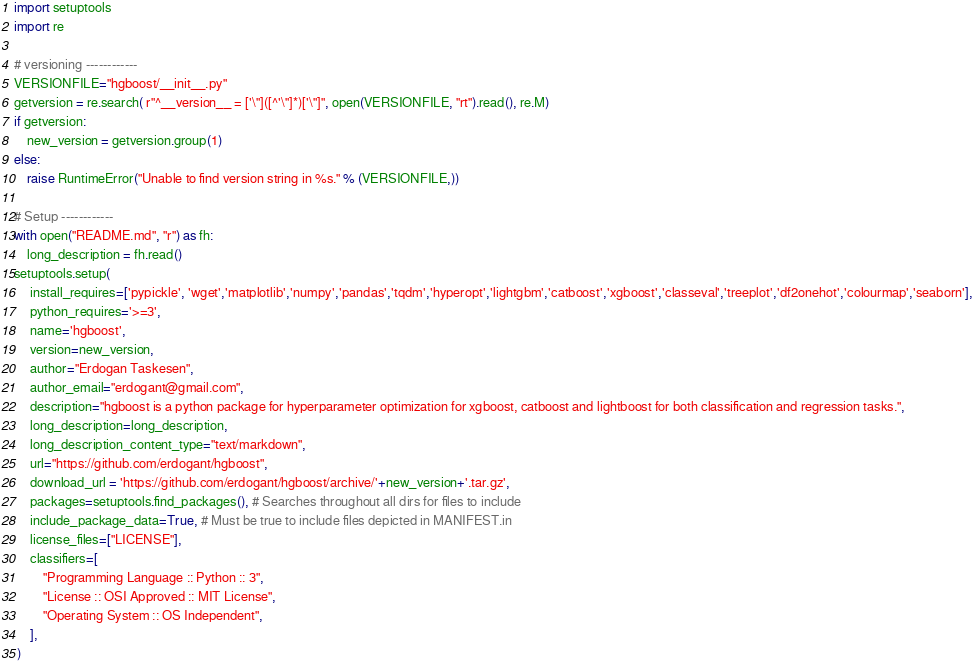<code> <loc_0><loc_0><loc_500><loc_500><_Python_>import setuptools
import re

# versioning ------------
VERSIONFILE="hgboost/__init__.py"
getversion = re.search( r"^__version__ = ['\"]([^'\"]*)['\"]", open(VERSIONFILE, "rt").read(), re.M)
if getversion:
    new_version = getversion.group(1)
else:
    raise RuntimeError("Unable to find version string in %s." % (VERSIONFILE,))

# Setup ------------
with open("README.md", "r") as fh:
    long_description = fh.read()
setuptools.setup(
     install_requires=['pypickle', 'wget','matplotlib','numpy','pandas','tqdm','hyperopt','lightgbm','catboost','xgboost','classeval','treeplot','df2onehot','colourmap','seaborn'],
     python_requires='>=3',
     name='hgboost',
     version=new_version,
     author="Erdogan Taskesen",
     author_email="erdogant@gmail.com",
     description="hgboost is a python package for hyperparameter optimization for xgboost, catboost and lightboost for both classification and regression tasks.",
     long_description=long_description,
     long_description_content_type="text/markdown",
     url="https://github.com/erdogant/hgboost",
	 download_url = 'https://github.com/erdogant/hgboost/archive/'+new_version+'.tar.gz',
     packages=setuptools.find_packages(), # Searches throughout all dirs for files to include
     include_package_data=True, # Must be true to include files depicted in MANIFEST.in
     license_files=["LICENSE"],
     classifiers=[
         "Programming Language :: Python :: 3",
         "License :: OSI Approved :: MIT License",
         "Operating System :: OS Independent",
     ],
 )
</code> 